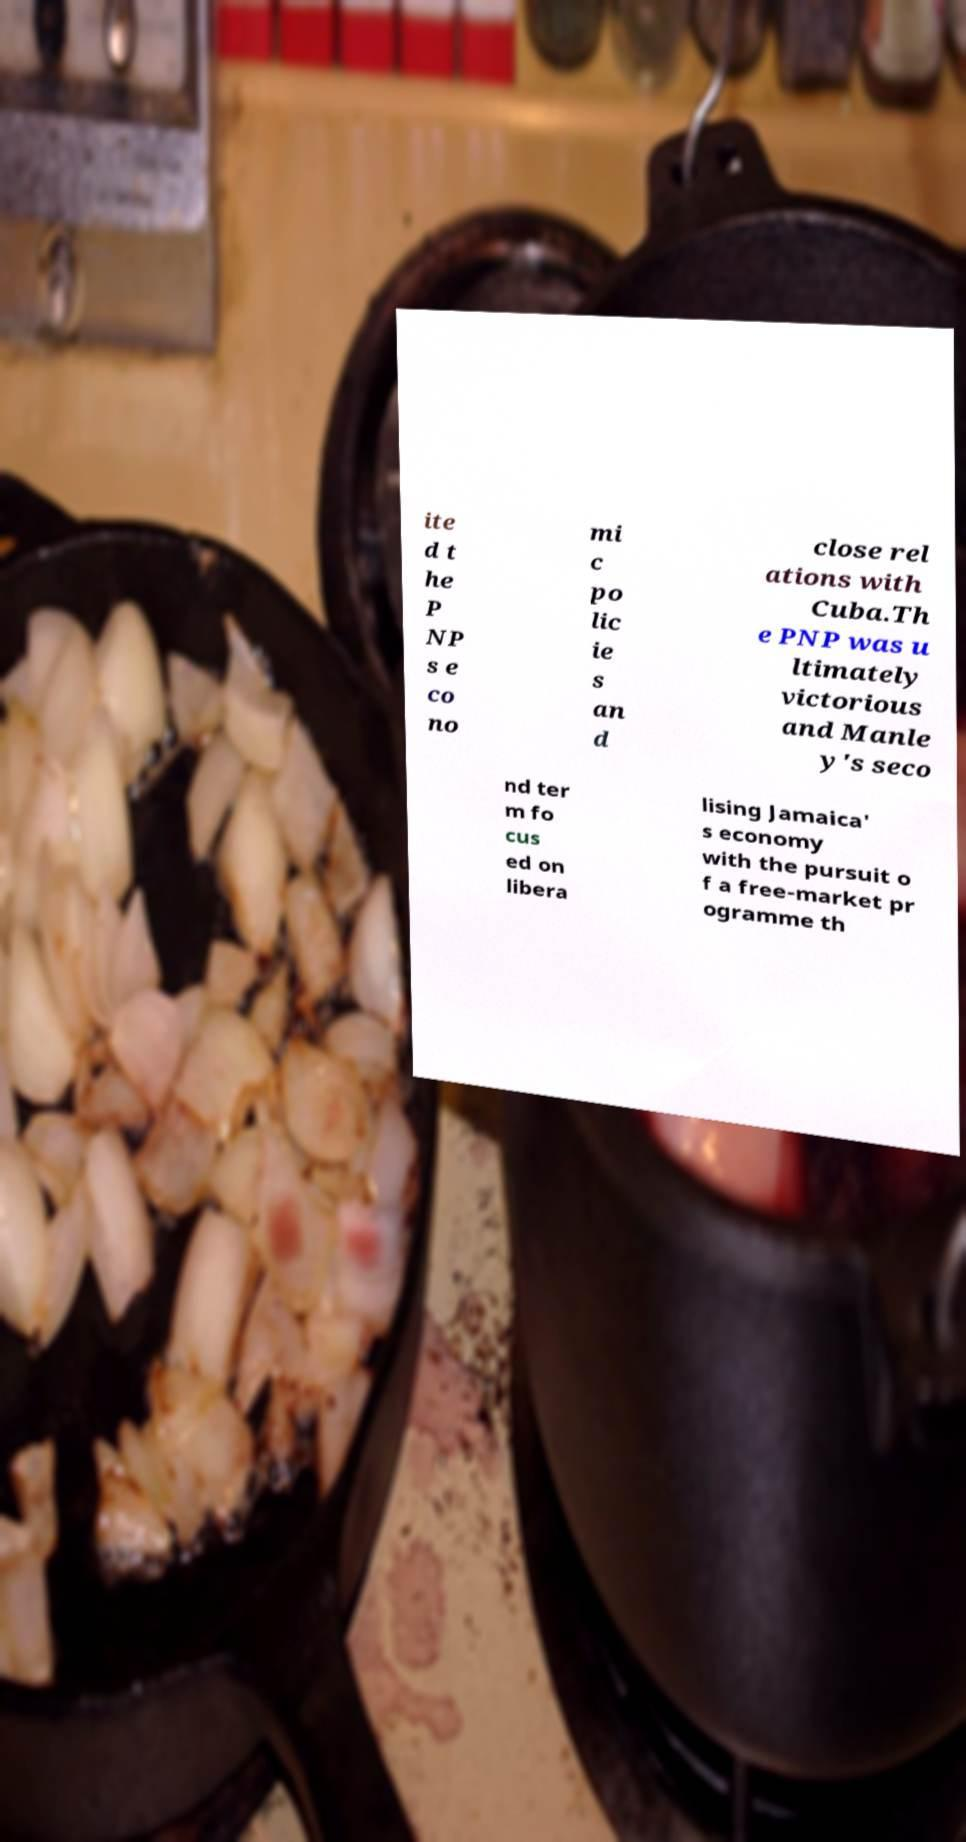I need the written content from this picture converted into text. Can you do that? ite d t he P NP s e co no mi c po lic ie s an d close rel ations with Cuba.Th e PNP was u ltimately victorious and Manle y's seco nd ter m fo cus ed on libera lising Jamaica' s economy with the pursuit o f a free-market pr ogramme th 